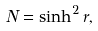<formula> <loc_0><loc_0><loc_500><loc_500>N = \sinh ^ { 2 } r ,</formula> 